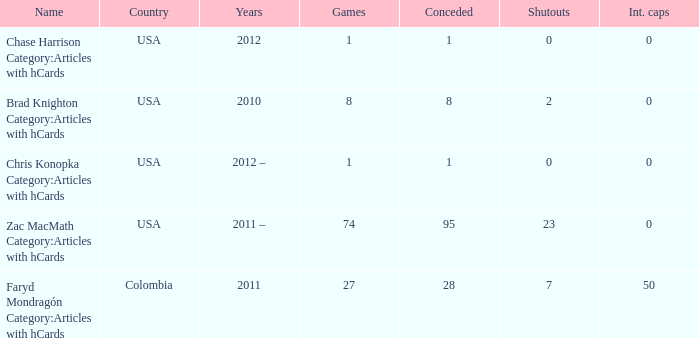In 2010 as the year, what's the amusement? 8.0. 